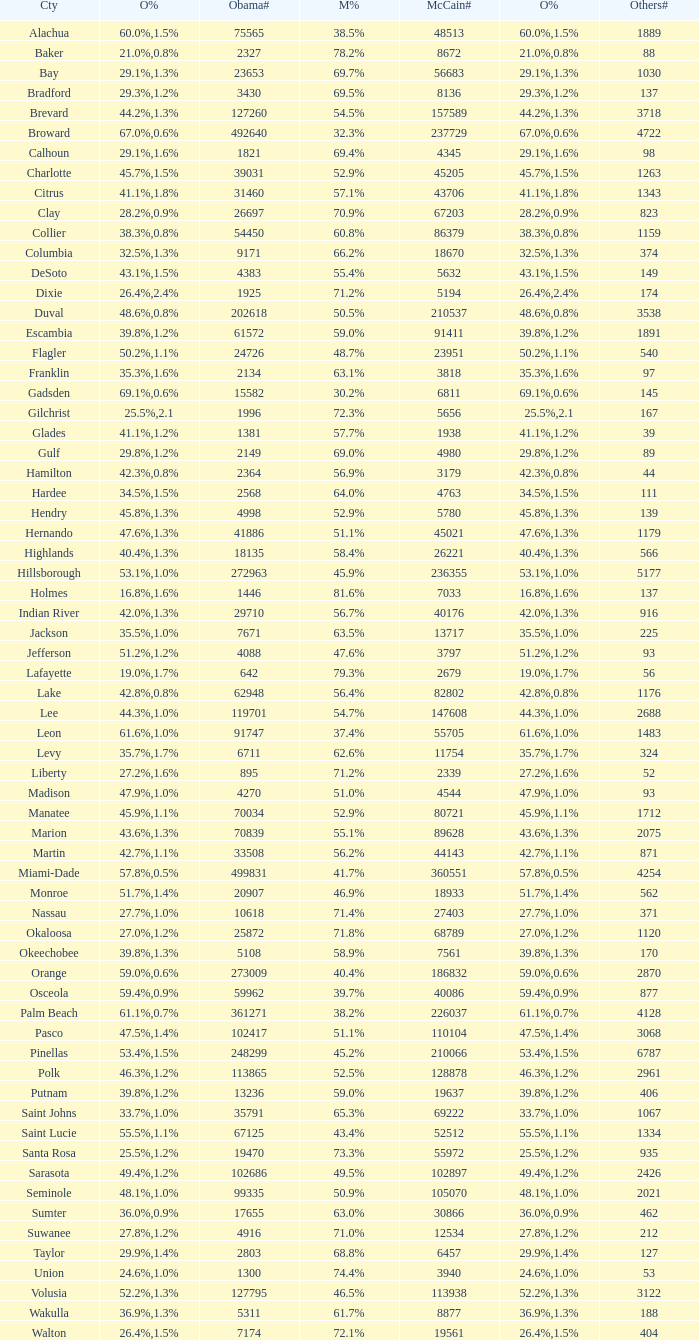How many numbers were recorded under McCain when Obama had 27.2% voters? 1.0. 